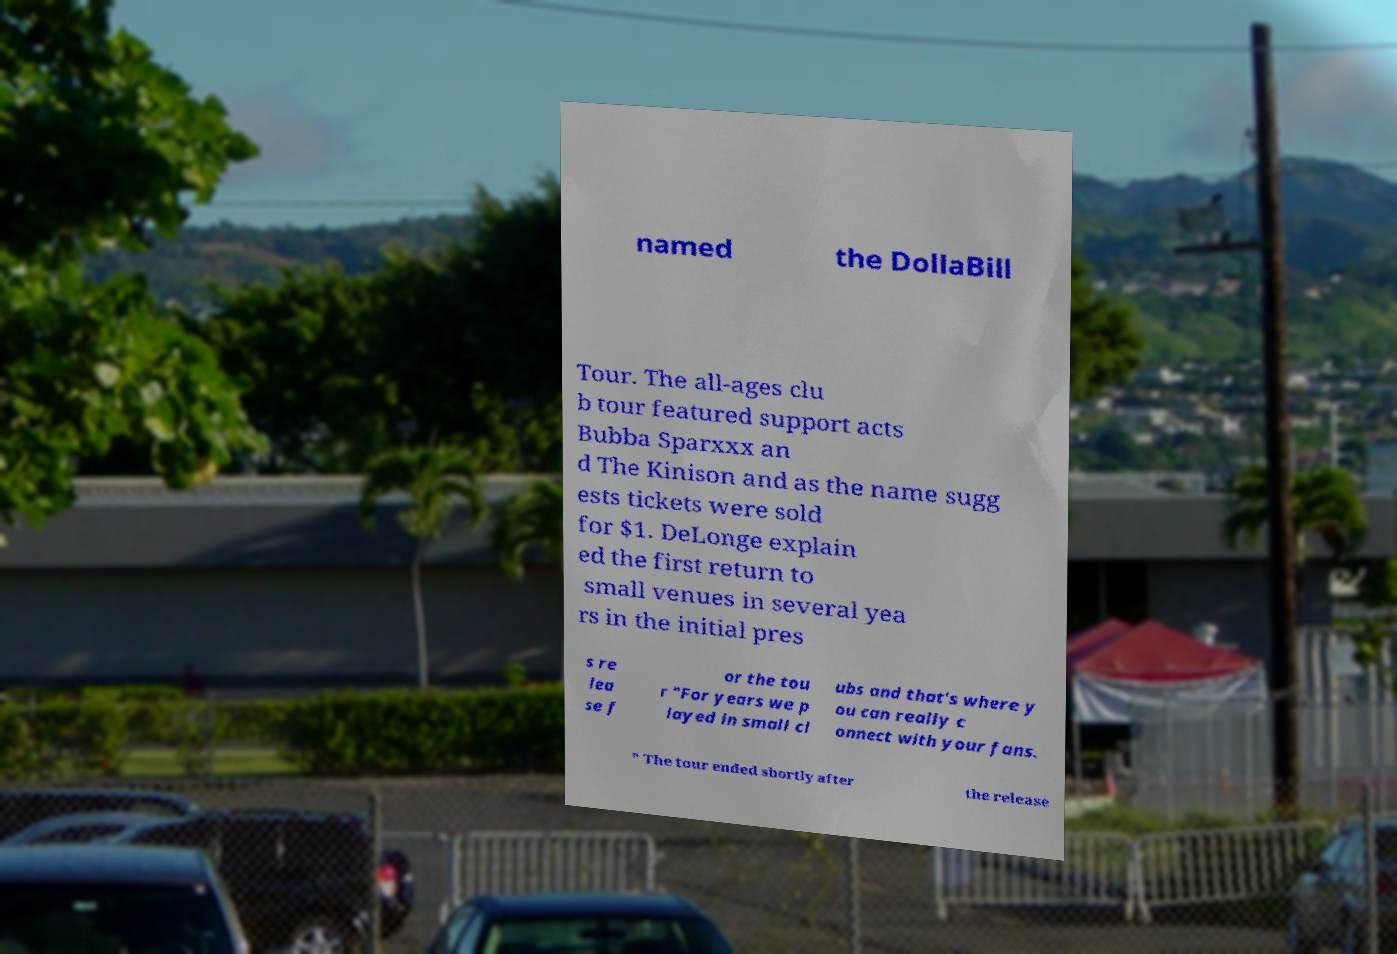Could you assist in decoding the text presented in this image and type it out clearly? named the DollaBill Tour. The all-ages clu b tour featured support acts Bubba Sparxxx an d The Kinison and as the name sugg ests tickets were sold for $1. DeLonge explain ed the first return to small venues in several yea rs in the initial pres s re lea se f or the tou r "For years we p layed in small cl ubs and that's where y ou can really c onnect with your fans. " The tour ended shortly after the release 